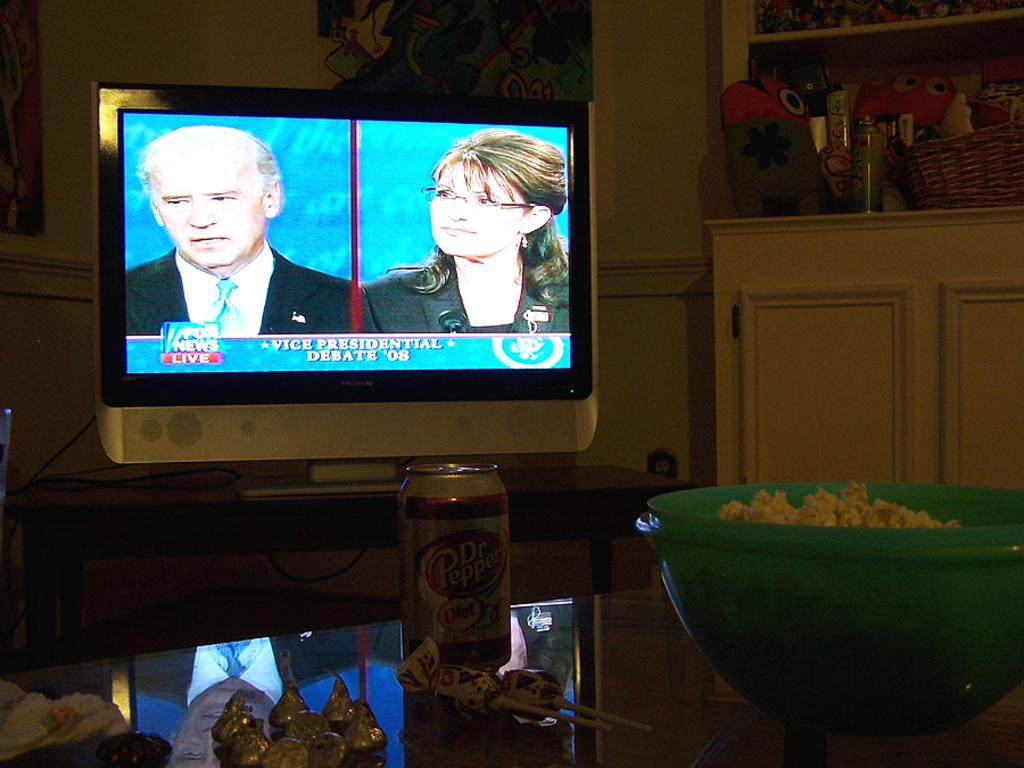<image>
Describe the image concisely. John is watching the VP debate between Joe Biden and Sarah Palin. 